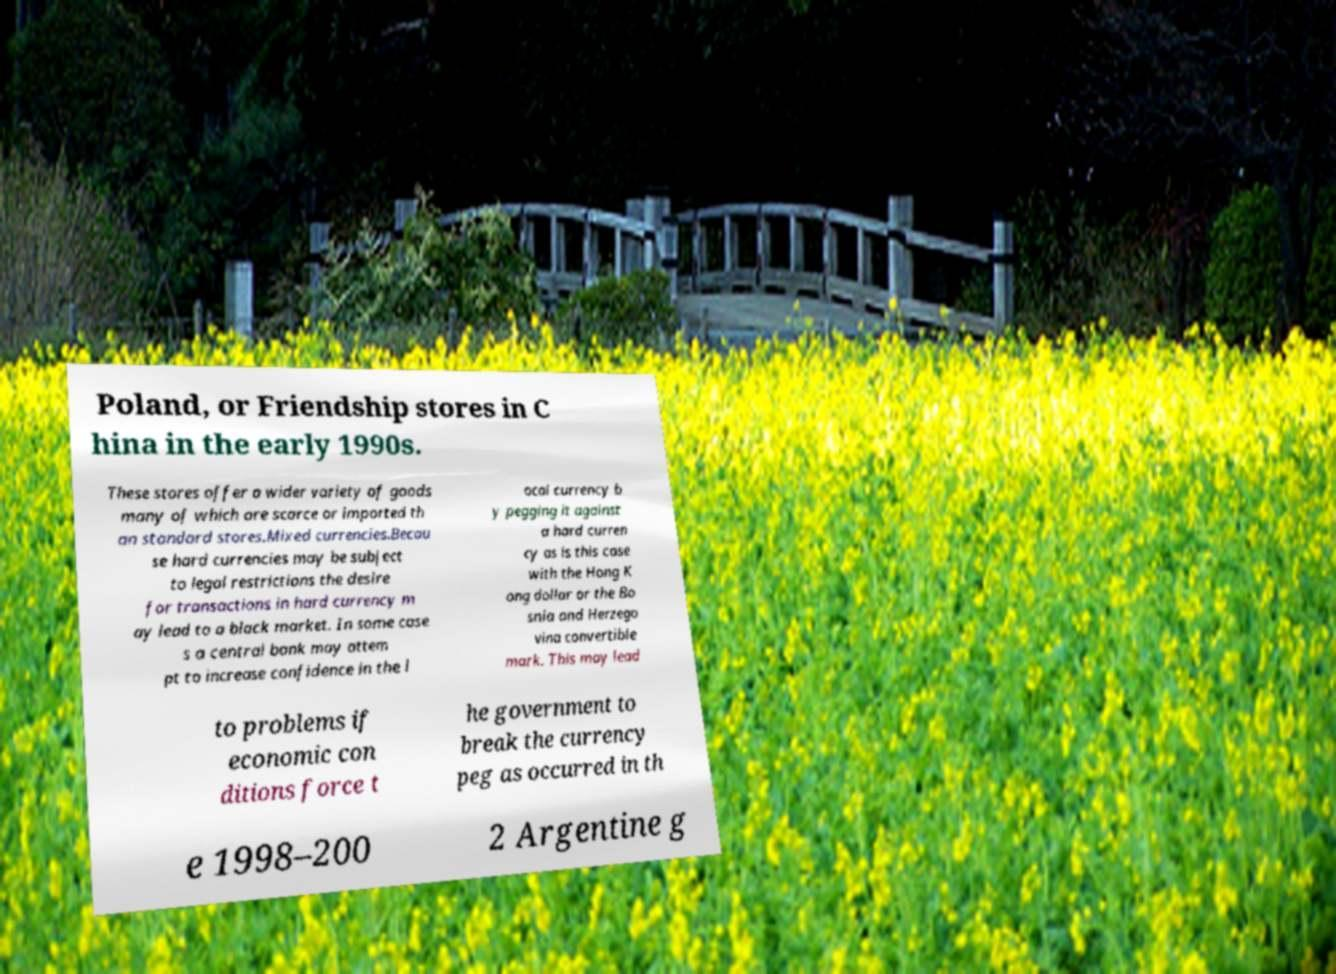Please identify and transcribe the text found in this image. Poland, or Friendship stores in C hina in the early 1990s. These stores offer a wider variety of goods many of which are scarce or imported th an standard stores.Mixed currencies.Becau se hard currencies may be subject to legal restrictions the desire for transactions in hard currency m ay lead to a black market. In some case s a central bank may attem pt to increase confidence in the l ocal currency b y pegging it against a hard curren cy as is this case with the Hong K ong dollar or the Bo snia and Herzego vina convertible mark. This may lead to problems if economic con ditions force t he government to break the currency peg as occurred in th e 1998–200 2 Argentine g 